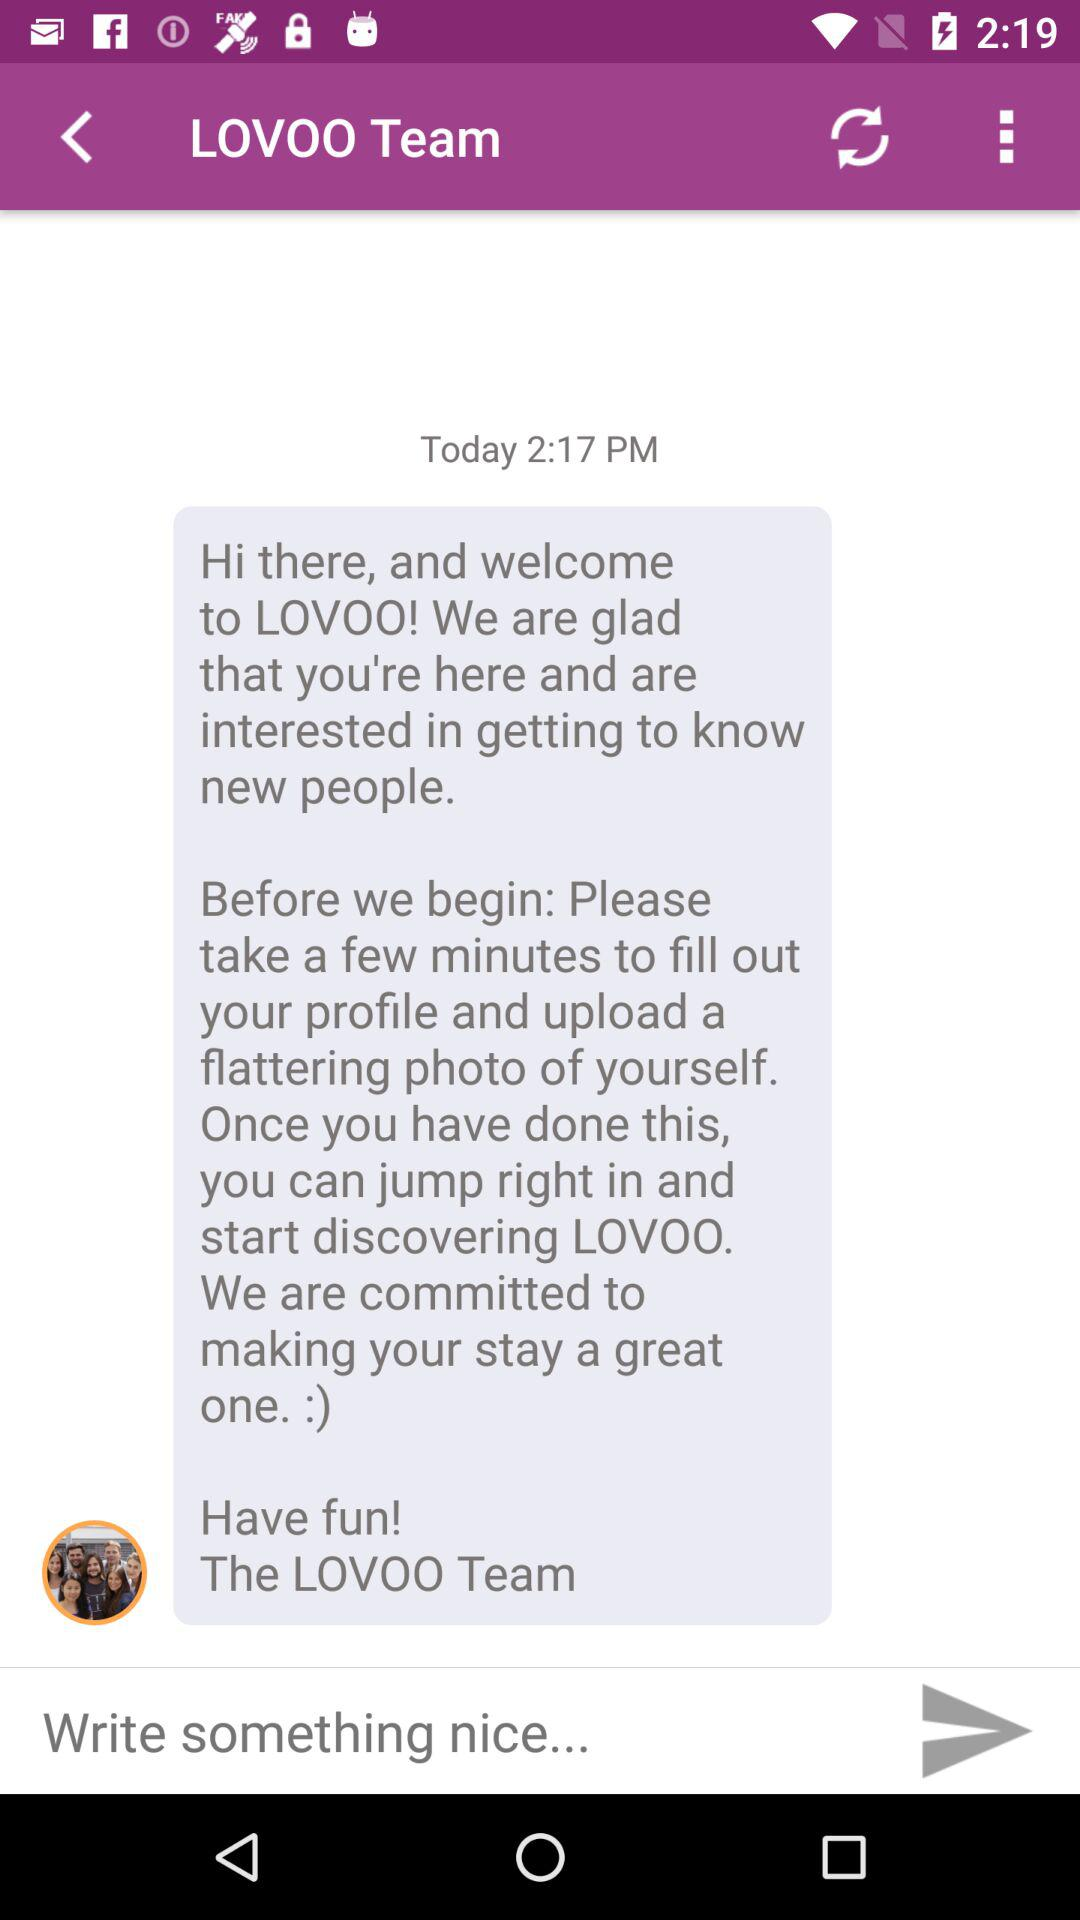When was the message received? The message was received today at 2:17 pm. 